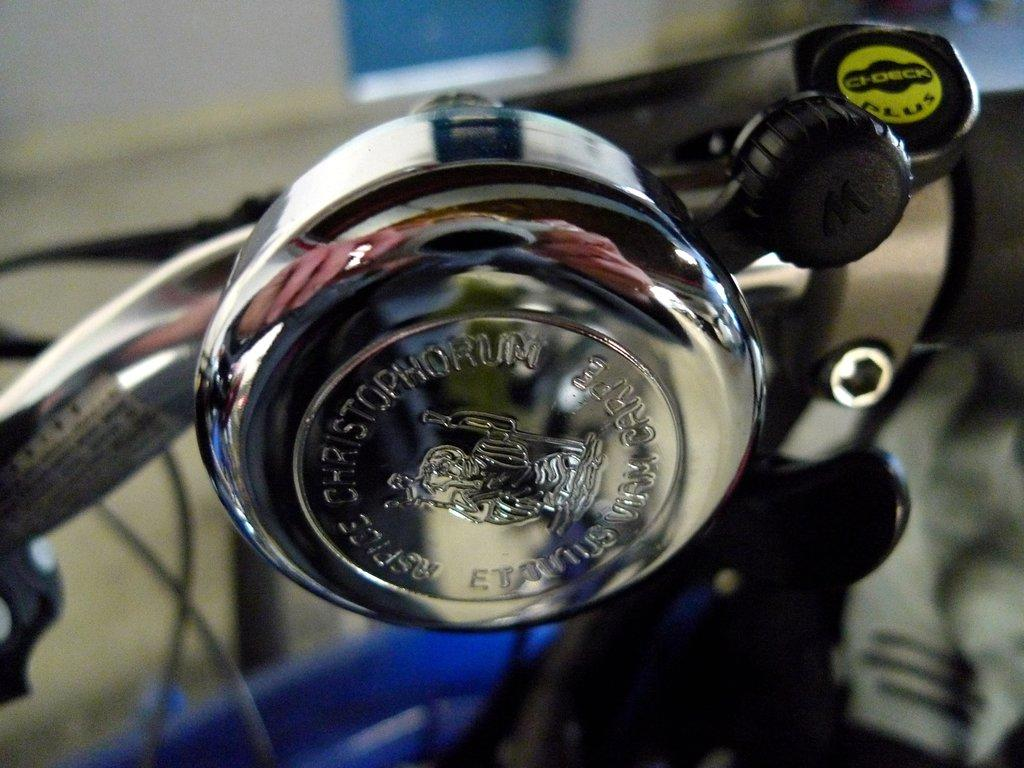What type of object is attached to the bicycle in the image? The metal object is attached to the bicycle in the image. Can you describe the metal object? Unfortunately, the facts provided do not give any details about the appearance or function of the metal object. What can be observed about the background of the image? The background of the image is blurred. Is there a spy hiding behind the metal object in the image? There is no mention of a spy or any hidden figures in the image. What type of box is placed next to the bicycle in the image? There is no box present in the image. Can you see a pig running in the background of the image? There is no pig or any animals visible in the image; the background is blurred. 